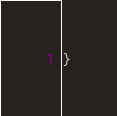Convert code to text. <code><loc_0><loc_0><loc_500><loc_500><_Java_>}
</code> 